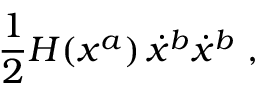Convert formula to latex. <formula><loc_0><loc_0><loc_500><loc_500>\frac { 1 } { 2 } H ( x ^ { a } ) \, \dot { x } ^ { b } \dot { x } ^ { b } \ ,</formula> 